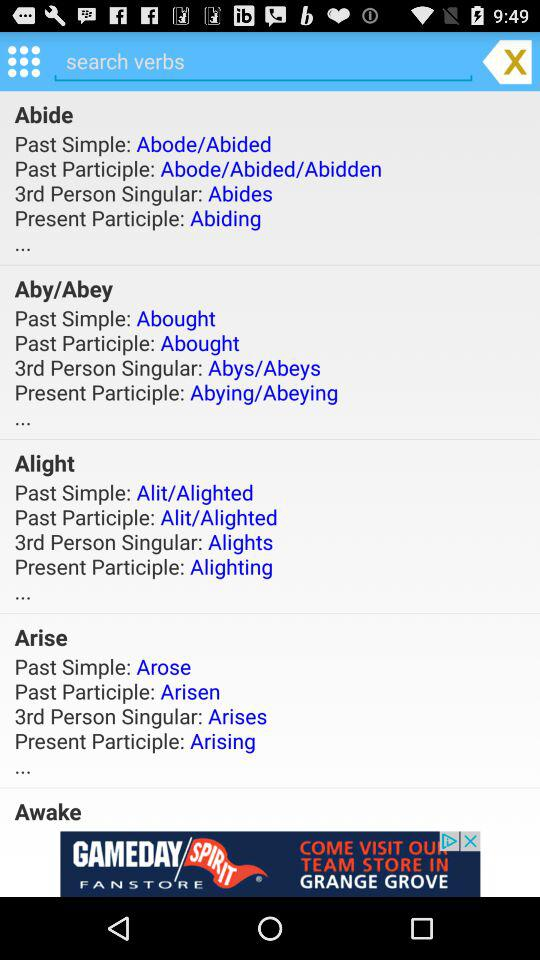What is the present participle of "Arise"? The present participle is "Arising". 